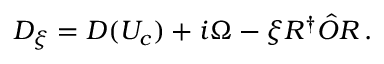<formula> <loc_0><loc_0><loc_500><loc_500>D _ { \xi } = D ( U _ { c } ) + i \Omega - \xi R ^ { \dagger } \hat { O } R \, .</formula> 